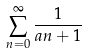<formula> <loc_0><loc_0><loc_500><loc_500>\sum _ { n = 0 } ^ { \infty } { \frac { 1 } { a n + 1 } }</formula> 